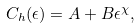Convert formula to latex. <formula><loc_0><loc_0><loc_500><loc_500>C _ { h } ( \epsilon ) = A + B \epsilon ^ { \chi } ,</formula> 